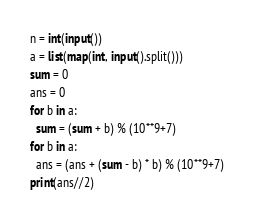Convert code to text. <code><loc_0><loc_0><loc_500><loc_500><_Python_>n = int(input())
a = list(map(int, input().split()))
sum = 0
ans = 0
for b in a:
  sum = (sum + b) % (10**9+7)
for b in a:
  ans = (ans + (sum - b) * b) % (10**9+7)
print(ans//2)</code> 